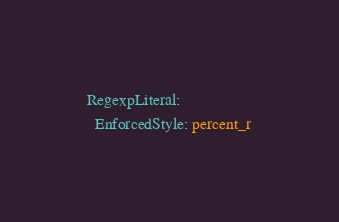Convert code to text. <code><loc_0><loc_0><loc_500><loc_500><_YAML_>RegexpLiteral:
  EnforcedStyle: percent_r
</code> 